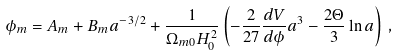Convert formula to latex. <formula><loc_0><loc_0><loc_500><loc_500>\phi _ { m } = A _ { m } + B _ { m } a ^ { - 3 / 2 } + \frac { 1 } { \Omega _ { m 0 } H _ { 0 } ^ { 2 } } \left ( - \frac { 2 } { 2 7 } \frac { d V } { d \phi } a ^ { 3 } - \frac { 2 \Theta } { 3 } \ln { a } \right ) \, ,</formula> 